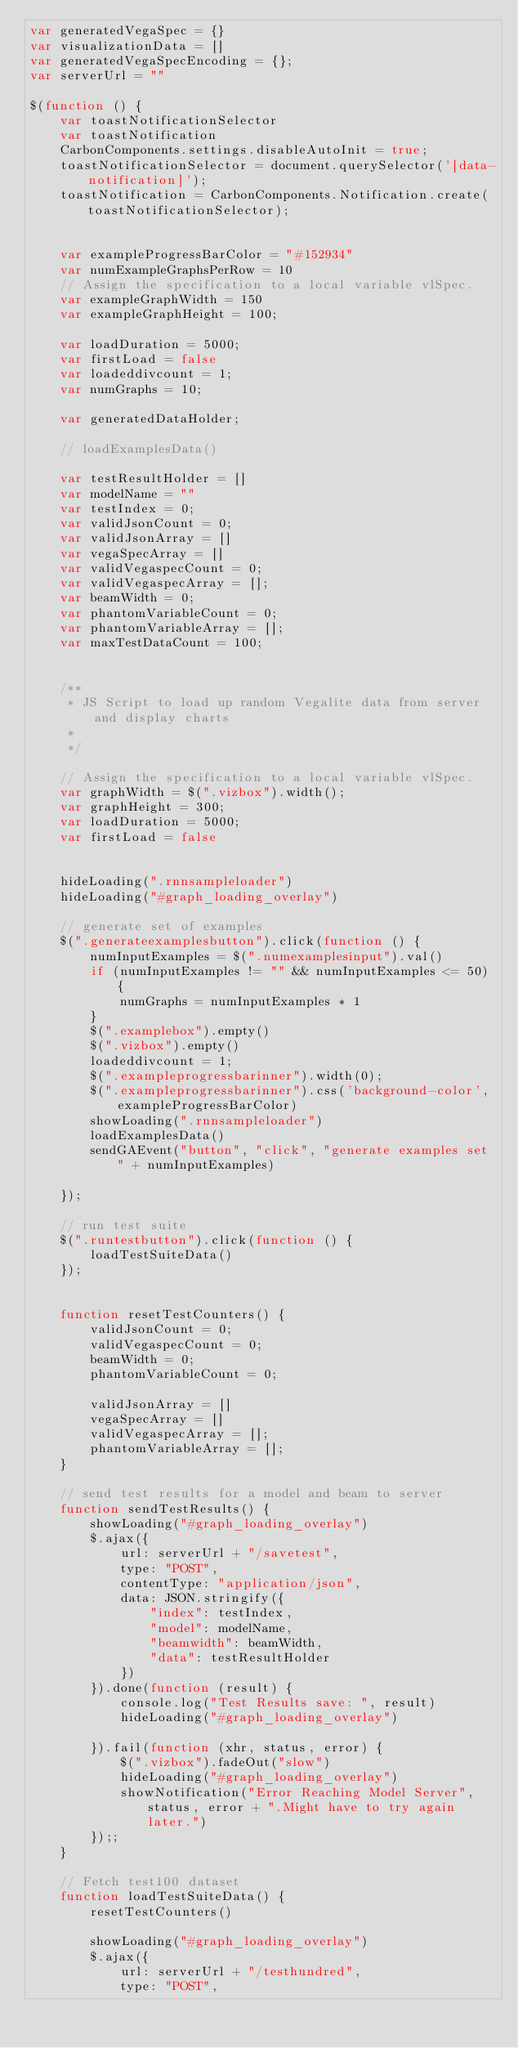Convert code to text. <code><loc_0><loc_0><loc_500><loc_500><_JavaScript_>var generatedVegaSpec = {}
var visualizationData = []
var generatedVegaSpecEncoding = {};
var serverUrl = ""

$(function () {
    var toastNotificationSelector
    var toastNotification
    CarbonComponents.settings.disableAutoInit = true;
    toastNotificationSelector = document.querySelector('[data-notification]');
    toastNotification = CarbonComponents.Notification.create(toastNotificationSelector);


    var exampleProgressBarColor = "#152934"
    var numExampleGraphsPerRow = 10
    // Assign the specification to a local variable vlSpec.
    var exampleGraphWidth = 150
    var exampleGraphHeight = 100;

    var loadDuration = 5000;
    var firstLoad = false
    var loadeddivcount = 1;
    var numGraphs = 10;

    var generatedDataHolder;

    // loadExamplesData() 

    var testResultHolder = []
    var modelName = ""
    var testIndex = 0;
    var validJsonCount = 0;
    var validJsonArray = []
    var vegaSpecArray = []
    var validVegaspecCount = 0;
    var validVegaspecArray = [];
    var beamWidth = 0;
    var phantomVariableCount = 0;
    var phantomVariableArray = [];
    var maxTestDataCount = 100;


    /**
     * JS Script to load up random Vegalite data from server and display charts
     * 
     */

    // Assign the specification to a local variable vlSpec.
    var graphWidth = $(".vizbox").width();
    var graphHeight = 300;
    var loadDuration = 5000;
    var firstLoad = false


    hideLoading(".rnnsampleloader")
    hideLoading("#graph_loading_overlay")

    // generate set of examples
    $(".generateexamplesbutton").click(function () {
        numInputExamples = $(".numexamplesinput").val()
        if (numInputExamples != "" && numInputExamples <= 50) {
            numGraphs = numInputExamples * 1
        }
        $(".examplebox").empty()
        $(".vizbox").empty()
        loadeddivcount = 1;
        $(".exampleprogressbarinner").width(0);
        $(".exampleprogressbarinner").css('background-color', exampleProgressBarColor)
        showLoading(".rnnsampleloader")
        loadExamplesData()
        sendGAEvent("button", "click", "generate examples set " + numInputExamples)

    });

    // run test suite
    $(".runtestbutton").click(function () {
        loadTestSuiteData()
    });


    function resetTestCounters() {
        validJsonCount = 0;
        validVegaspecCount = 0;
        beamWidth = 0;
        phantomVariableCount = 0;

        validJsonArray = []
        vegaSpecArray = []
        validVegaspecArray = [];
        phantomVariableArray = [];
    }

    // send test results for a model and beam to server
    function sendTestResults() {
        showLoading("#graph_loading_overlay")
        $.ajax({
            url: serverUrl + "/savetest",
            type: "POST",
            contentType: "application/json",
            data: JSON.stringify({
                "index": testIndex,
                "model": modelName,
                "beamwidth": beamWidth,
                "data": testResultHolder
            })
        }).done(function (result) {
            console.log("Test Results save: ", result)
            hideLoading("#graph_loading_overlay")

        }).fail(function (xhr, status, error) {
            $(".vizbox").fadeOut("slow")
            hideLoading("#graph_loading_overlay")
            showNotification("Error Reaching Model Server", status, error + ".Might have to try again later.")
        });;
    }

    // Fetch test100 dataset
    function loadTestSuiteData() {
        resetTestCounters()

        showLoading("#graph_loading_overlay")
        $.ajax({
            url: serverUrl + "/testhundred",
            type: "POST",</code> 